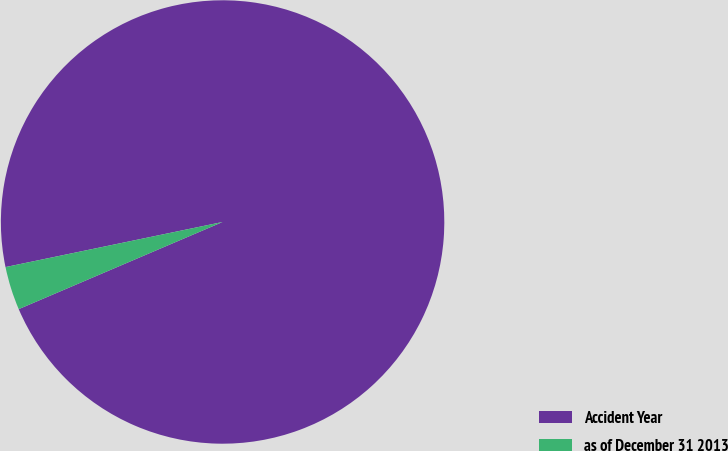<chart> <loc_0><loc_0><loc_500><loc_500><pie_chart><fcel>Accident Year<fcel>as of December 31 2013<nl><fcel>96.83%<fcel>3.17%<nl></chart> 